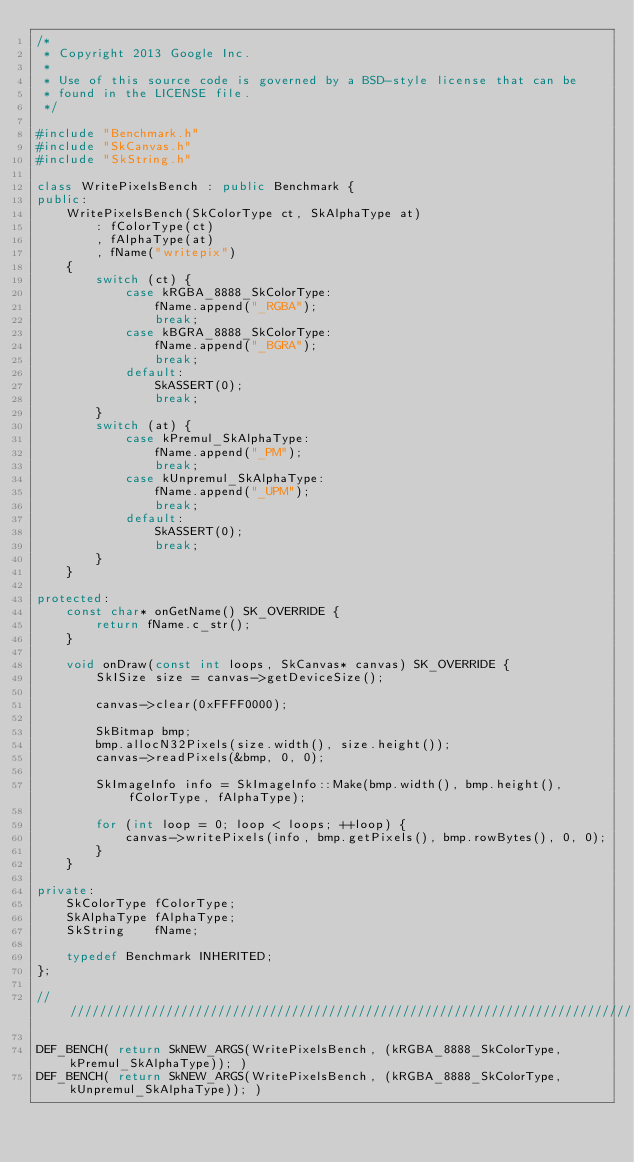<code> <loc_0><loc_0><loc_500><loc_500><_C++_>/*
 * Copyright 2013 Google Inc.
 *
 * Use of this source code is governed by a BSD-style license that can be
 * found in the LICENSE file.
 */

#include "Benchmark.h"
#include "SkCanvas.h"
#include "SkString.h"

class WritePixelsBench : public Benchmark {
public:
    WritePixelsBench(SkColorType ct, SkAlphaType at)
        : fColorType(ct)
        , fAlphaType(at)
        , fName("writepix")
    {
        switch (ct) {
            case kRGBA_8888_SkColorType:
                fName.append("_RGBA");
                break;
            case kBGRA_8888_SkColorType:
                fName.append("_BGRA");
                break;
            default:
                SkASSERT(0);
                break;
        }
        switch (at) {
            case kPremul_SkAlphaType:
                fName.append("_PM");
                break;
            case kUnpremul_SkAlphaType:
                fName.append("_UPM");
                break;
            default:
                SkASSERT(0);
                break;
        }
    }

protected:
    const char* onGetName() SK_OVERRIDE {
        return fName.c_str();
    }

    void onDraw(const int loops, SkCanvas* canvas) SK_OVERRIDE {
        SkISize size = canvas->getDeviceSize();

        canvas->clear(0xFFFF0000);

        SkBitmap bmp;
        bmp.allocN32Pixels(size.width(), size.height());
        canvas->readPixels(&bmp, 0, 0);

        SkImageInfo info = SkImageInfo::Make(bmp.width(), bmp.height(), fColorType, fAlphaType);

        for (int loop = 0; loop < loops; ++loop) {
            canvas->writePixels(info, bmp.getPixels(), bmp.rowBytes(), 0, 0);
        }
    }

private:
    SkColorType fColorType;
    SkAlphaType fAlphaType;
    SkString    fName;

    typedef Benchmark INHERITED;
};

//////////////////////////////////////////////////////////////////////////////

DEF_BENCH( return SkNEW_ARGS(WritePixelsBench, (kRGBA_8888_SkColorType, kPremul_SkAlphaType)); )
DEF_BENCH( return SkNEW_ARGS(WritePixelsBench, (kRGBA_8888_SkColorType, kUnpremul_SkAlphaType)); )
</code> 